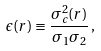Convert formula to latex. <formula><loc_0><loc_0><loc_500><loc_500>\epsilon ( r ) \equiv \frac { \sigma _ { c } ^ { 2 } ( r ) } { \sigma _ { 1 } \sigma _ { 2 } } \, ,</formula> 